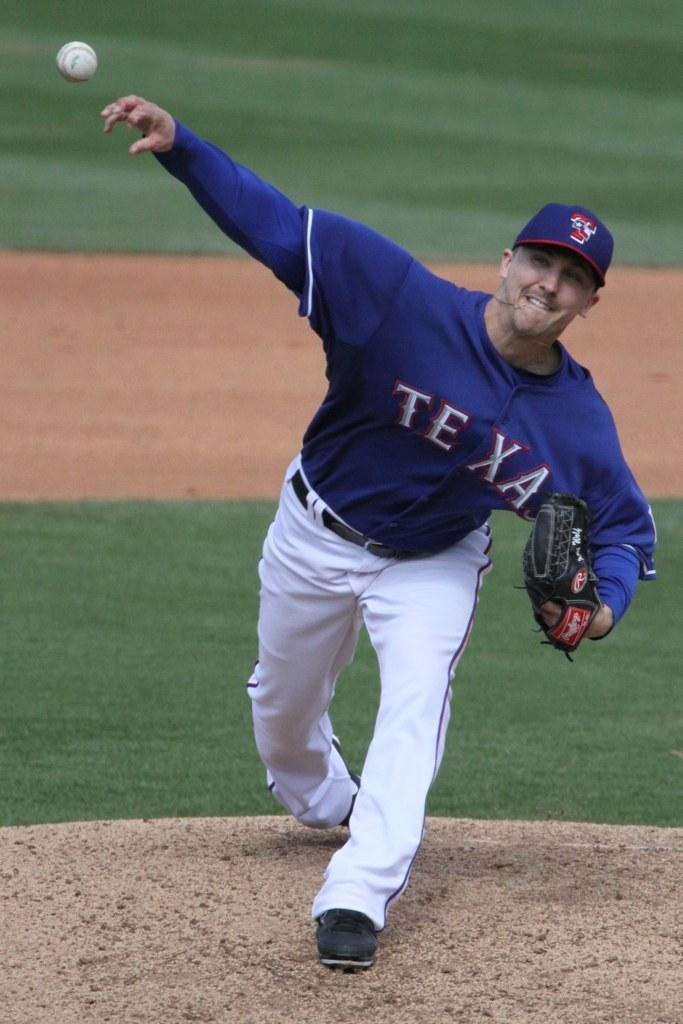<image>
Describe the image concisely. A Texas Rangers pitcher is throwing the ball from the mound. 